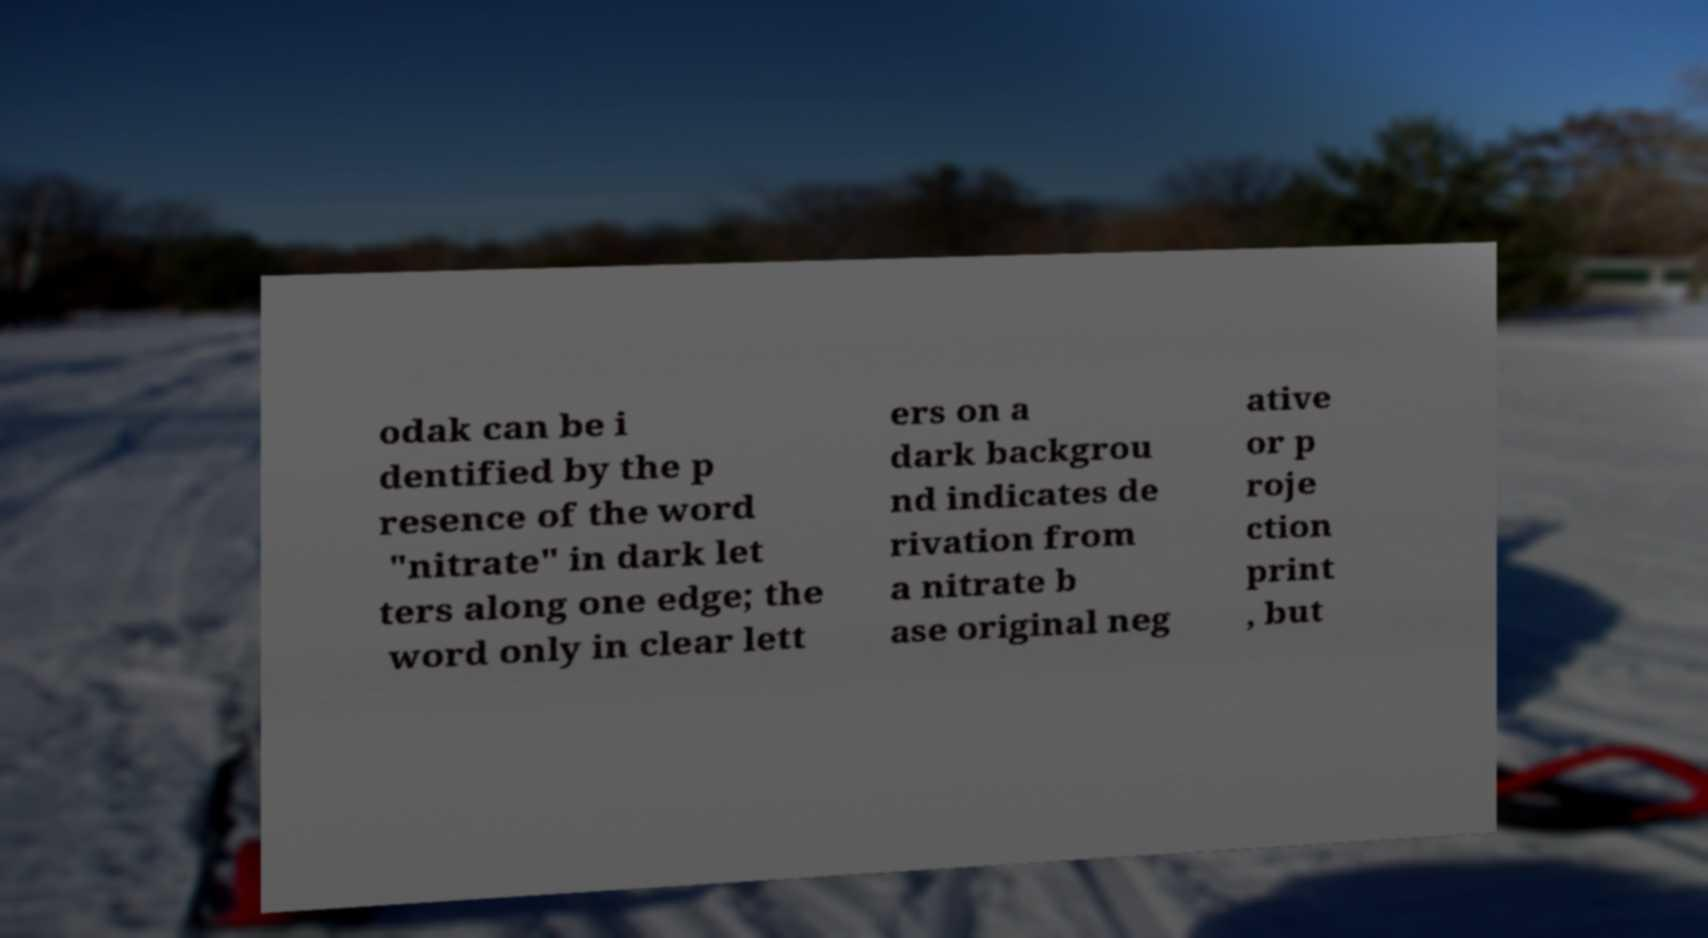Could you assist in decoding the text presented in this image and type it out clearly? odak can be i dentified by the p resence of the word "nitrate" in dark let ters along one edge; the word only in clear lett ers on a dark backgrou nd indicates de rivation from a nitrate b ase original neg ative or p roje ction print , but 